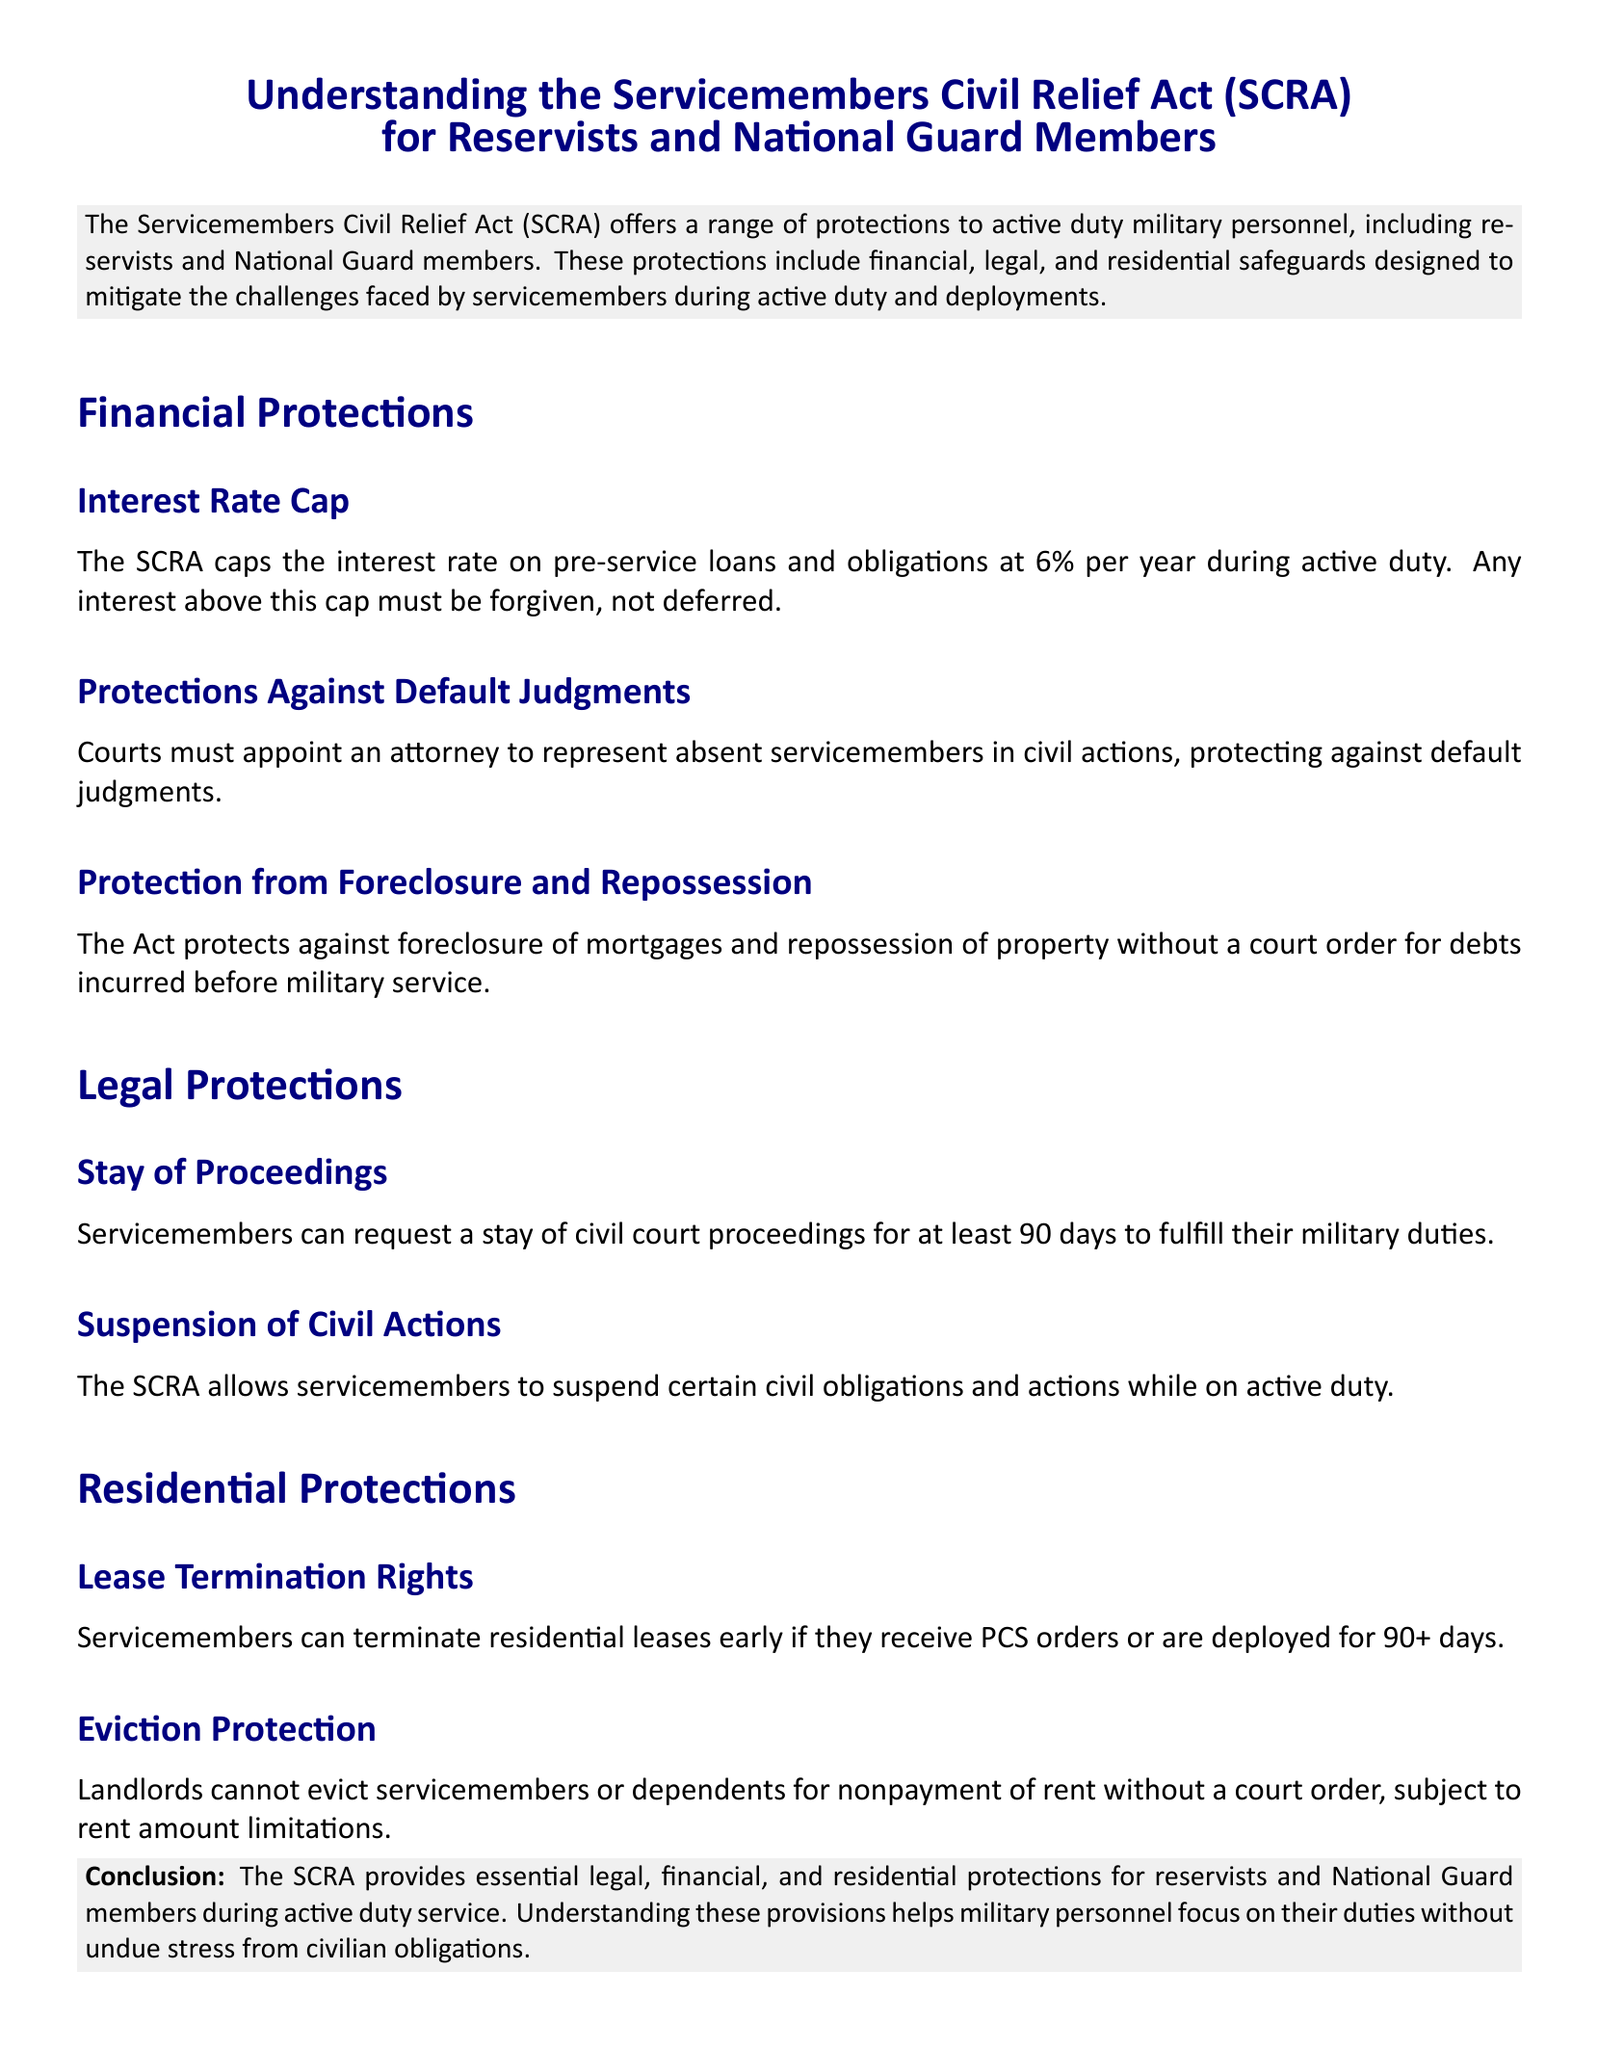What does SCRA stand for? SCRA is mentioned as an abbreviation in the title of the document, representing the Servicemembers Civil Relief Act.
Answer: Servicemembers Civil Relief Act What is the interest rate cap under the SCRA? The document specifies that the SCRA caps the interest rate on loans and obligations at a certain percentage during active duty.
Answer: 6% What must courts do for absent servicemembers? The document states that courts must take specific actions to protect servicemembers who are not present for civil actions.
Answer: Appoint an attorney What protection does SCRA offer regarding eviction? The section on residential protections describes the conditions under which landlords cannot evict servicemembers.
Answer: Court order What is the minimum period for requesting a stay of proceedings? The document provides details about the duration for which servicemembers can request a stay.
Answer: 90 days Under what circumstances can servicemembers terminate residential leases? The document outlines specific orders or deployments that allow for lease termination.
Answer: Receiving PCS orders or deployment for 90+ days What does the conclusion section highlight about SCRA? The conclusion summarizes the impact of the SCRA on servicemembers, focused on alleviating stress related to civilian obligations.
Answer: Essential protections What type of document is this? Based on content and structure, we identify its classification within a specific legal context.
Answer: Legal brief 